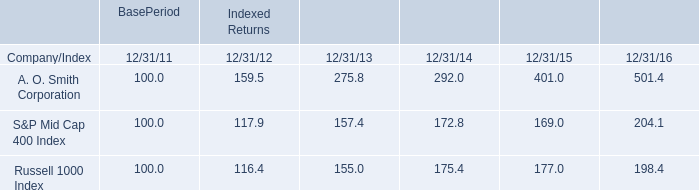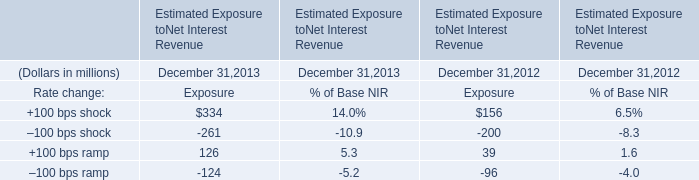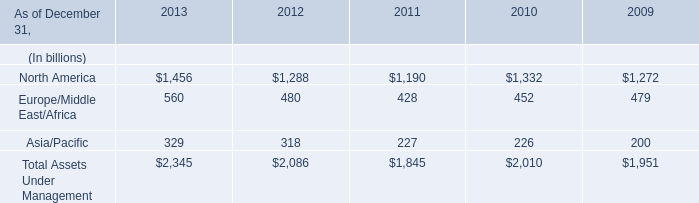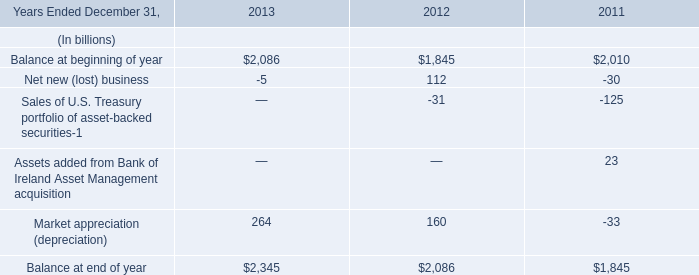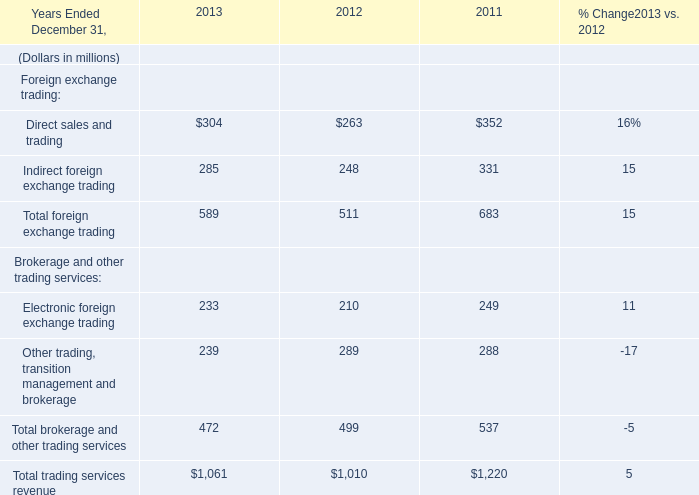Which year is Other trading, transition management and brokerage the highest? 
Answer: 2012. 